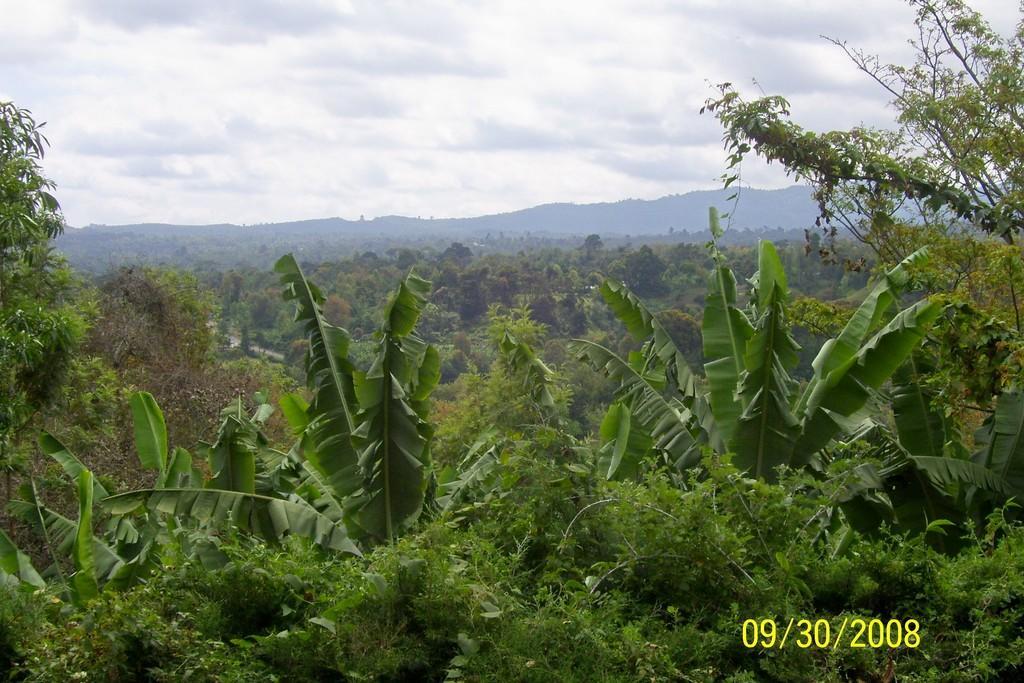Could you give a brief overview of what you see in this image? In this image, there are so many trees. In the background, we can see the cloudy sky and hills. In the bottom right side of the image, there is a watermark. It represents date. 